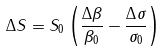Convert formula to latex. <formula><loc_0><loc_0><loc_500><loc_500>\Delta S = S _ { 0 } \left ( \frac { \Delta \beta } { \beta _ { 0 } } - \frac { \Delta \sigma } { \sigma _ { 0 } } \right )</formula> 